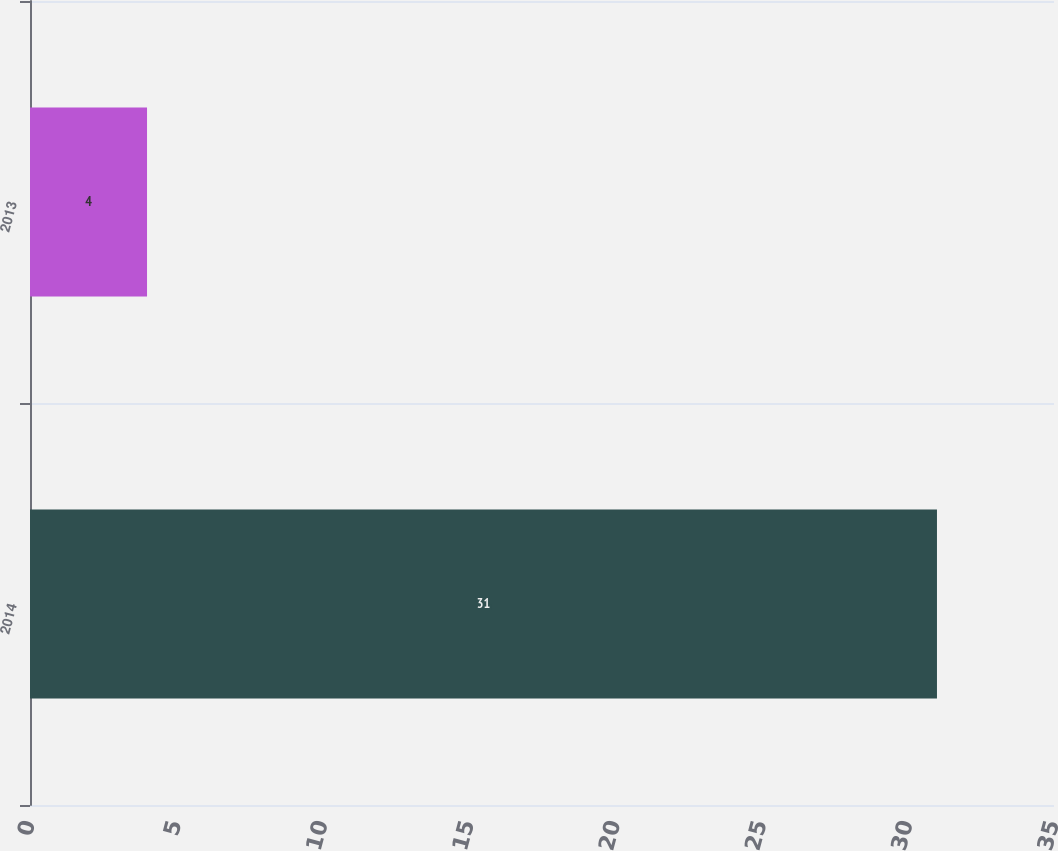Convert chart. <chart><loc_0><loc_0><loc_500><loc_500><bar_chart><fcel>2014<fcel>2013<nl><fcel>31<fcel>4<nl></chart> 